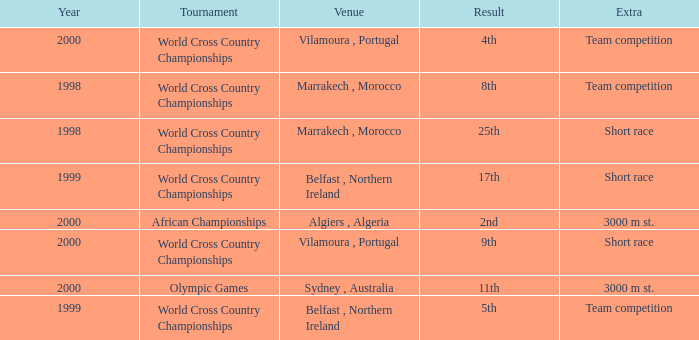Tell me the highest year for result of 9th 2000.0. 